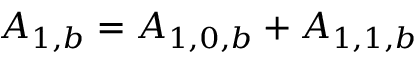Convert formula to latex. <formula><loc_0><loc_0><loc_500><loc_500>{ A _ { 1 , b } } = { A _ { 1 , 0 , b } } + { A _ { 1 , 1 , b } }</formula> 